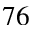<formula> <loc_0><loc_0><loc_500><loc_500>7 6</formula> 